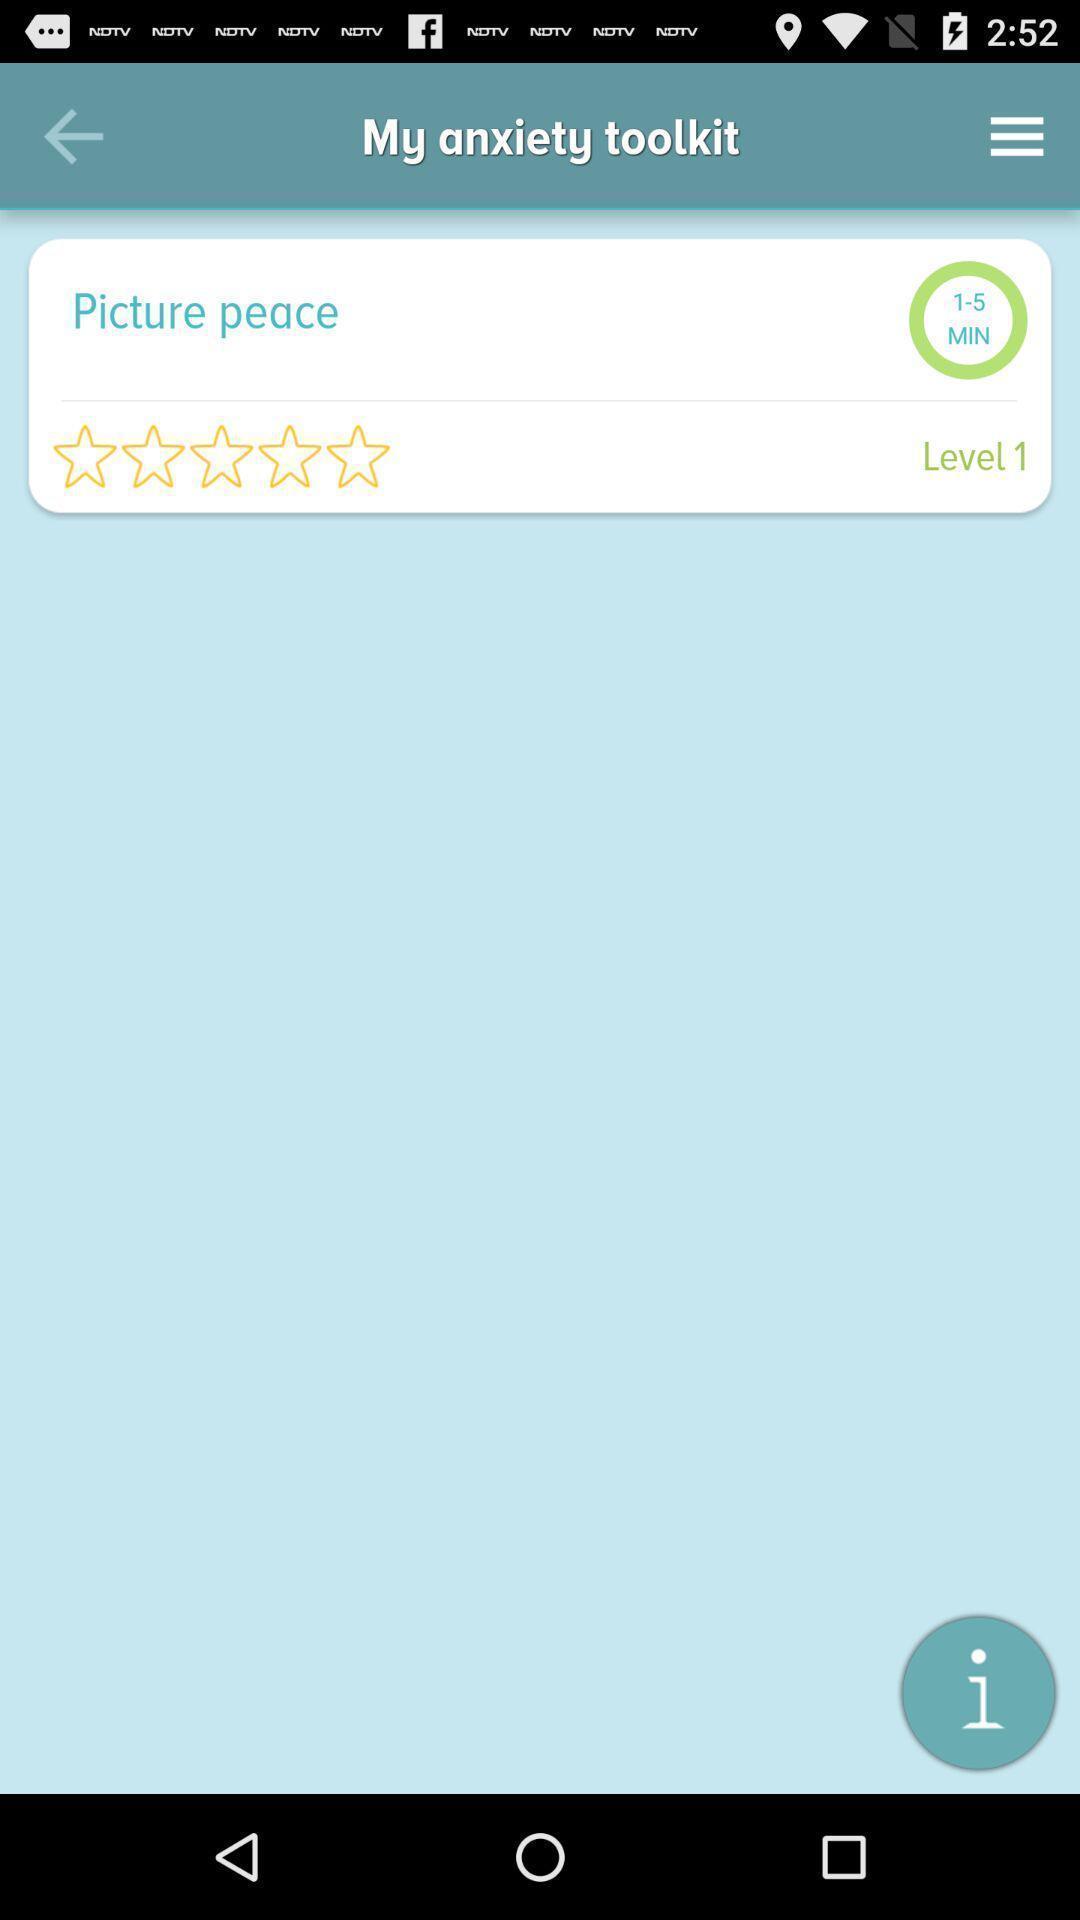What can you discern from this picture? Page showing rating. 